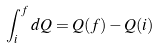Convert formula to latex. <formula><loc_0><loc_0><loc_500><loc_500>\int _ { i } ^ { f } d Q = Q ( f ) - Q ( i )</formula> 